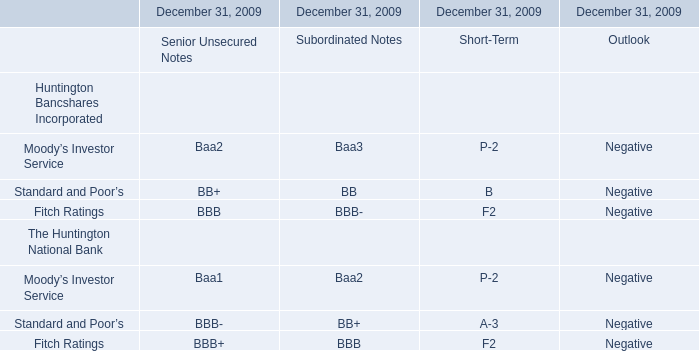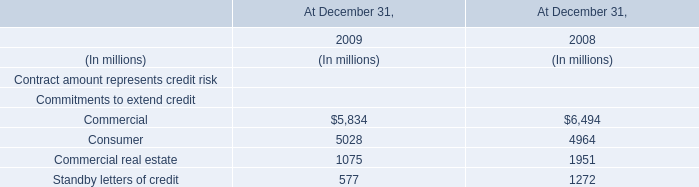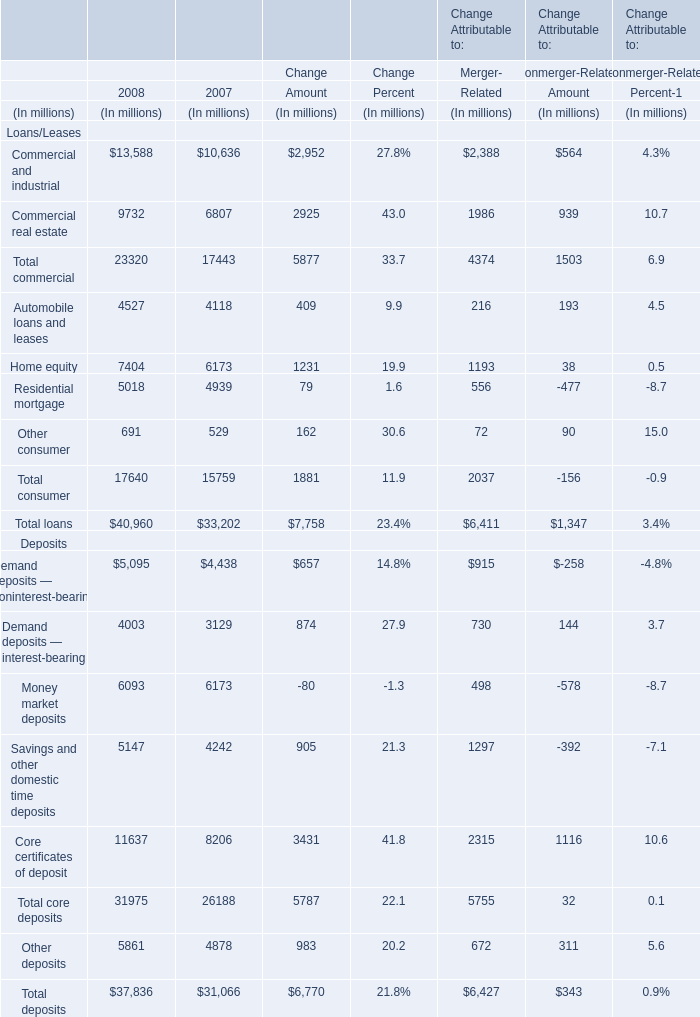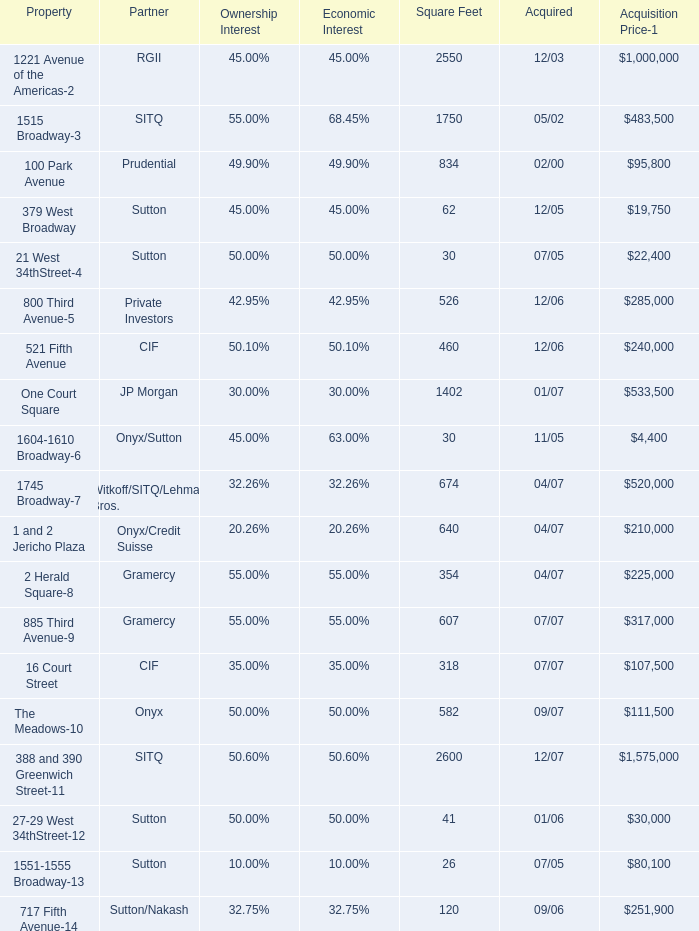What was the total amount of the Residential mortgage in the years where Home equity is greater than 7000? (in million) 
Answer: 5018. 